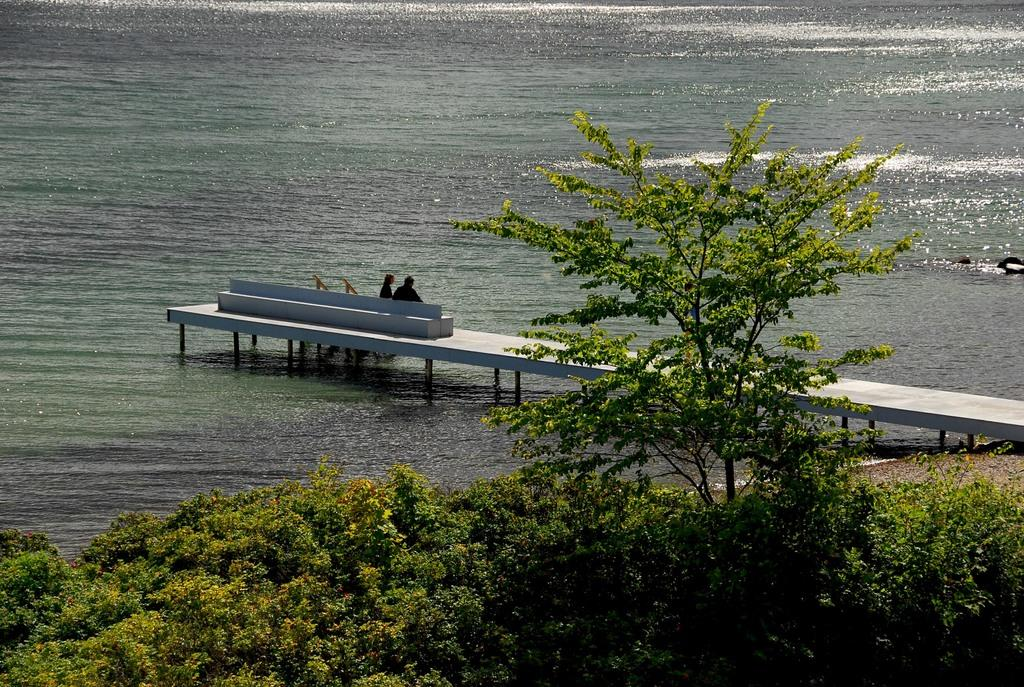What type of natural feature is present in the picture? There is a river in the picture. What can be found at the bottom of the picture? There are plants and a tree at the bottom of the picture. How many people are in the middle of the picture? There are two members in the middle of the picture. What type of shelf can be seen in the picture? There is no shelf present in the picture. What line is visible in the picture? There is no line visible in the picture. 